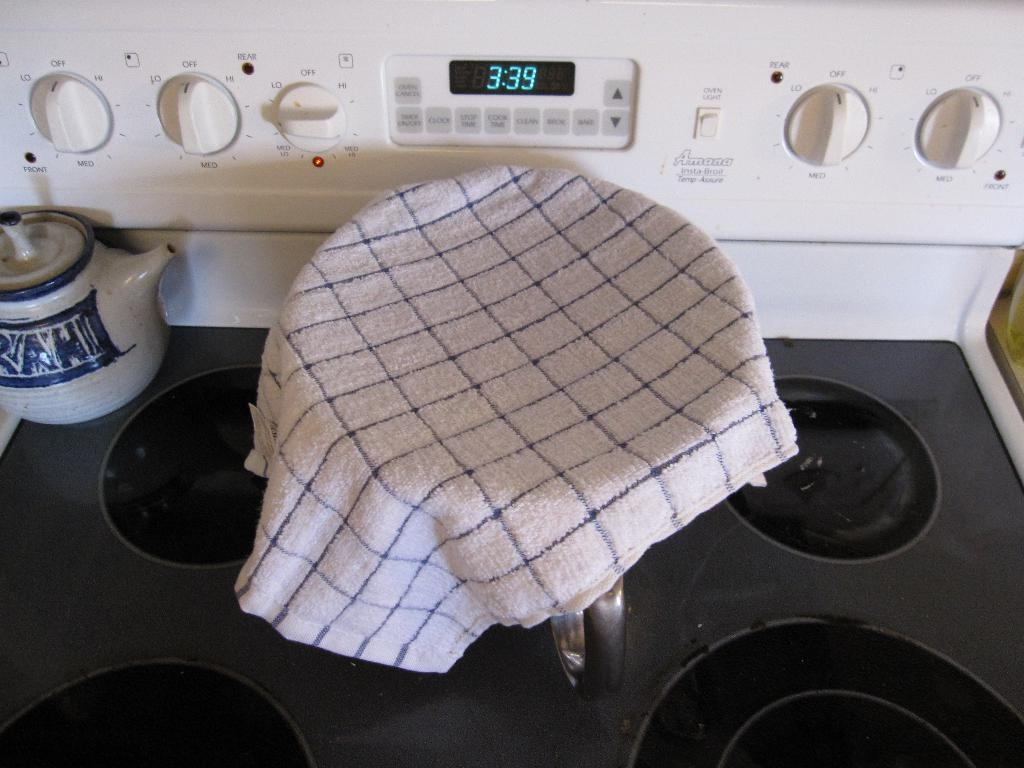<image>
Present a compact description of the photo's key features. An oven clock reads 3:39 as something sits in a bowl with a towel over it. 